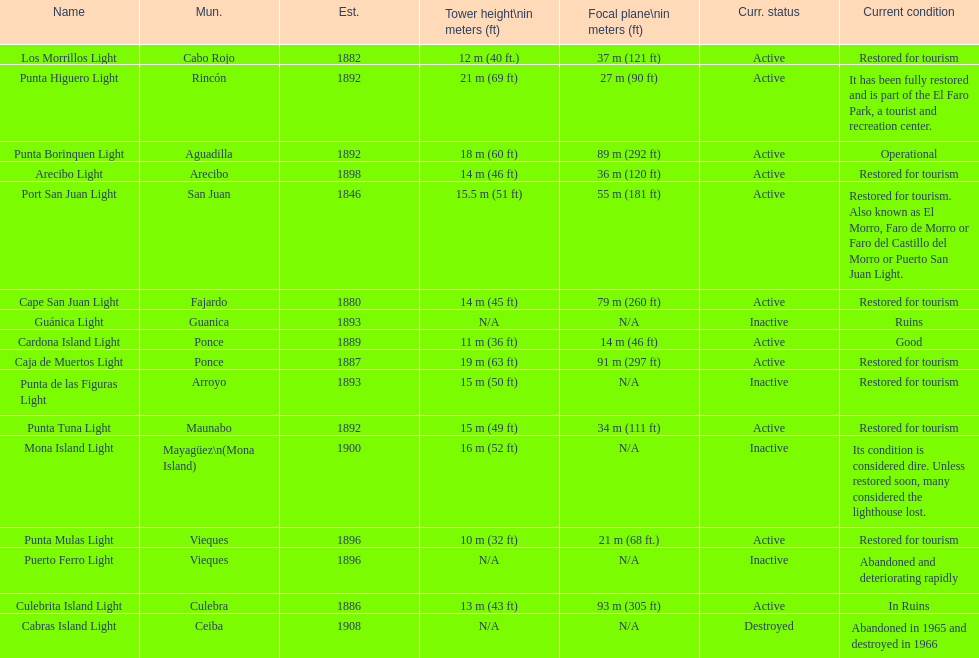Cardona island light and caja de muertos light are both located in what municipality? Ponce. 